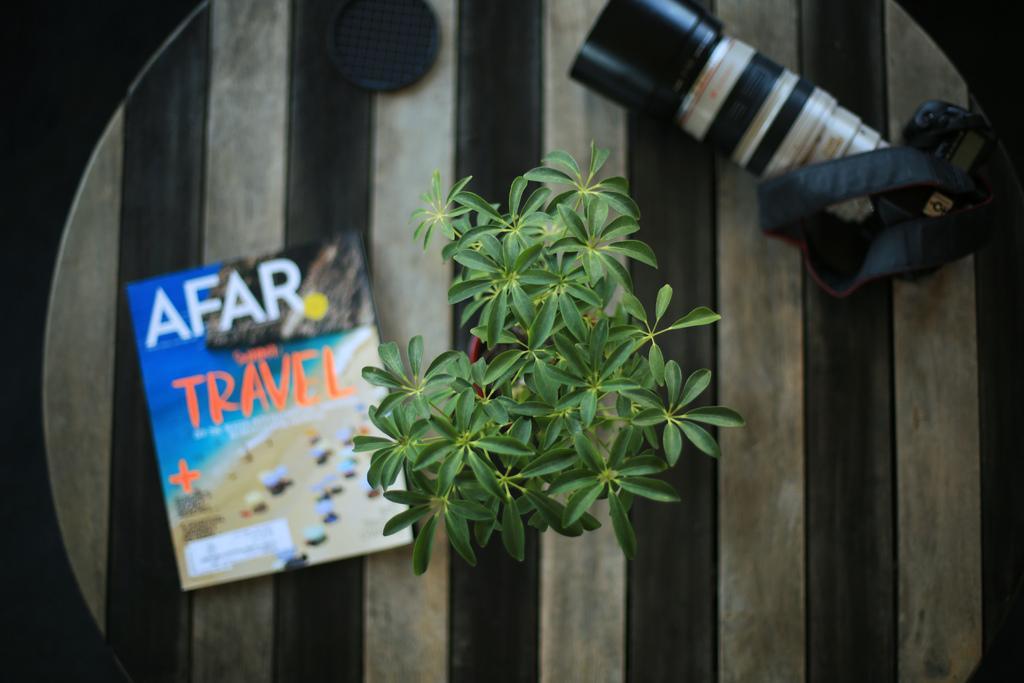Please provide a concise description of this image. In the picture I can see a book, a camera and a plant pot on a wooden table. 